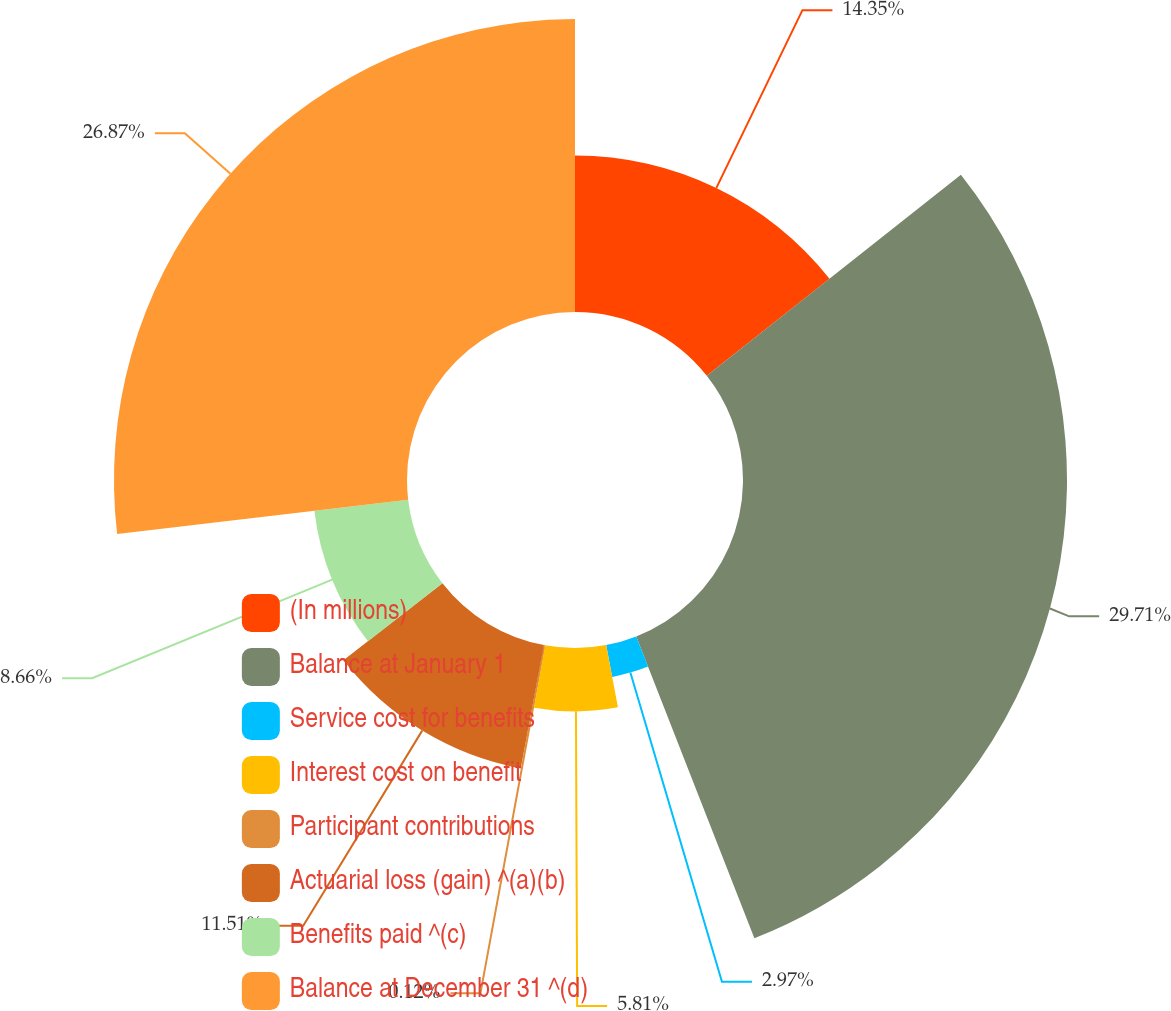Convert chart to OTSL. <chart><loc_0><loc_0><loc_500><loc_500><pie_chart><fcel>(In millions)<fcel>Balance at January 1<fcel>Service cost for benefits<fcel>Interest cost on benefit<fcel>Participant contributions<fcel>Actuarial loss (gain) ^(a)(b)<fcel>Benefits paid ^(c)<fcel>Balance at December 31 ^(d)<nl><fcel>14.35%<fcel>29.71%<fcel>2.97%<fcel>5.81%<fcel>0.12%<fcel>11.51%<fcel>8.66%<fcel>26.87%<nl></chart> 